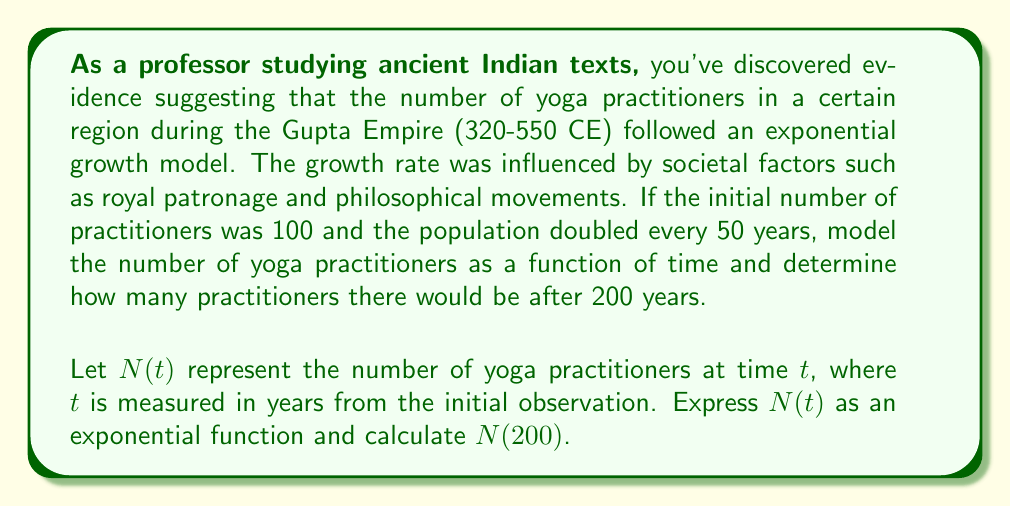Can you answer this question? To solve this problem, we'll follow these steps:

1) The general form of an exponential growth function is:

   $$N(t) = N_0 \cdot e^{rt}$$

   where $N_0$ is the initial population, $r$ is the growth rate, and $t$ is time.

2) We're given that $N_0 = 100$ and the population doubles every 50 years.

3) To find $r$, we can use the doubling time formula:

   $$2 = e^{r \cdot 50}$$

4) Taking the natural log of both sides:

   $$\ln(2) = r \cdot 50$$

5) Solving for $r$:

   $$r = \frac{\ln(2)}{50} \approx 0.0139$$

6) Now we can write our full exponential function:

   $$N(t) = 100 \cdot e^{0.0139t}$$

7) To find the number of practitioners after 200 years, we calculate $N(200)$:

   $$N(200) = 100 \cdot e^{0.0139 \cdot 200}$$

8) Evaluating this expression:

   $$N(200) = 100 \cdot e^{2.78} \approx 1608.95$$
Answer: The number of yoga practitioners can be modeled by the function $N(t) = 100 \cdot e^{0.0139t}$, where $t$ is the time in years. After 200 years, there would be approximately 1,609 yoga practitioners. 